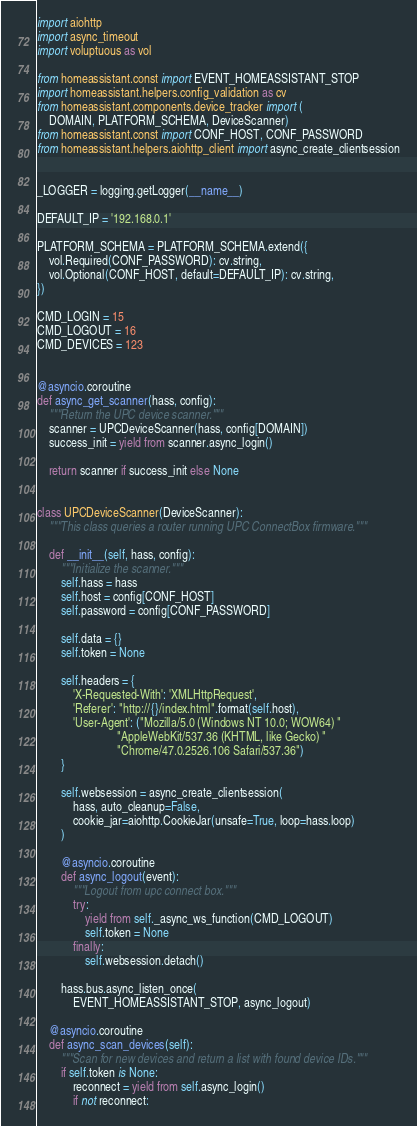Convert code to text. <code><loc_0><loc_0><loc_500><loc_500><_Python_>import aiohttp
import async_timeout
import voluptuous as vol

from homeassistant.const import EVENT_HOMEASSISTANT_STOP
import homeassistant.helpers.config_validation as cv
from homeassistant.components.device_tracker import (
    DOMAIN, PLATFORM_SCHEMA, DeviceScanner)
from homeassistant.const import CONF_HOST, CONF_PASSWORD
from homeassistant.helpers.aiohttp_client import async_create_clientsession


_LOGGER = logging.getLogger(__name__)

DEFAULT_IP = '192.168.0.1'

PLATFORM_SCHEMA = PLATFORM_SCHEMA.extend({
    vol.Required(CONF_PASSWORD): cv.string,
    vol.Optional(CONF_HOST, default=DEFAULT_IP): cv.string,
})

CMD_LOGIN = 15
CMD_LOGOUT = 16
CMD_DEVICES = 123


@asyncio.coroutine
def async_get_scanner(hass, config):
    """Return the UPC device scanner."""
    scanner = UPCDeviceScanner(hass, config[DOMAIN])
    success_init = yield from scanner.async_login()

    return scanner if success_init else None


class UPCDeviceScanner(DeviceScanner):
    """This class queries a router running UPC ConnectBox firmware."""

    def __init__(self, hass, config):
        """Initialize the scanner."""
        self.hass = hass
        self.host = config[CONF_HOST]
        self.password = config[CONF_PASSWORD]

        self.data = {}
        self.token = None

        self.headers = {
            'X-Requested-With': 'XMLHttpRequest',
            'Referer': "http://{}/index.html".format(self.host),
            'User-Agent': ("Mozilla/5.0 (Windows NT 10.0; WOW64) "
                           "AppleWebKit/537.36 (KHTML, like Gecko) "
                           "Chrome/47.0.2526.106 Safari/537.36")
        }

        self.websession = async_create_clientsession(
            hass, auto_cleanup=False,
            cookie_jar=aiohttp.CookieJar(unsafe=True, loop=hass.loop)
        )

        @asyncio.coroutine
        def async_logout(event):
            """Logout from upc connect box."""
            try:
                yield from self._async_ws_function(CMD_LOGOUT)
                self.token = None
            finally:
                self.websession.detach()

        hass.bus.async_listen_once(
            EVENT_HOMEASSISTANT_STOP, async_logout)

    @asyncio.coroutine
    def async_scan_devices(self):
        """Scan for new devices and return a list with found device IDs."""
        if self.token is None:
            reconnect = yield from self.async_login()
            if not reconnect:</code> 